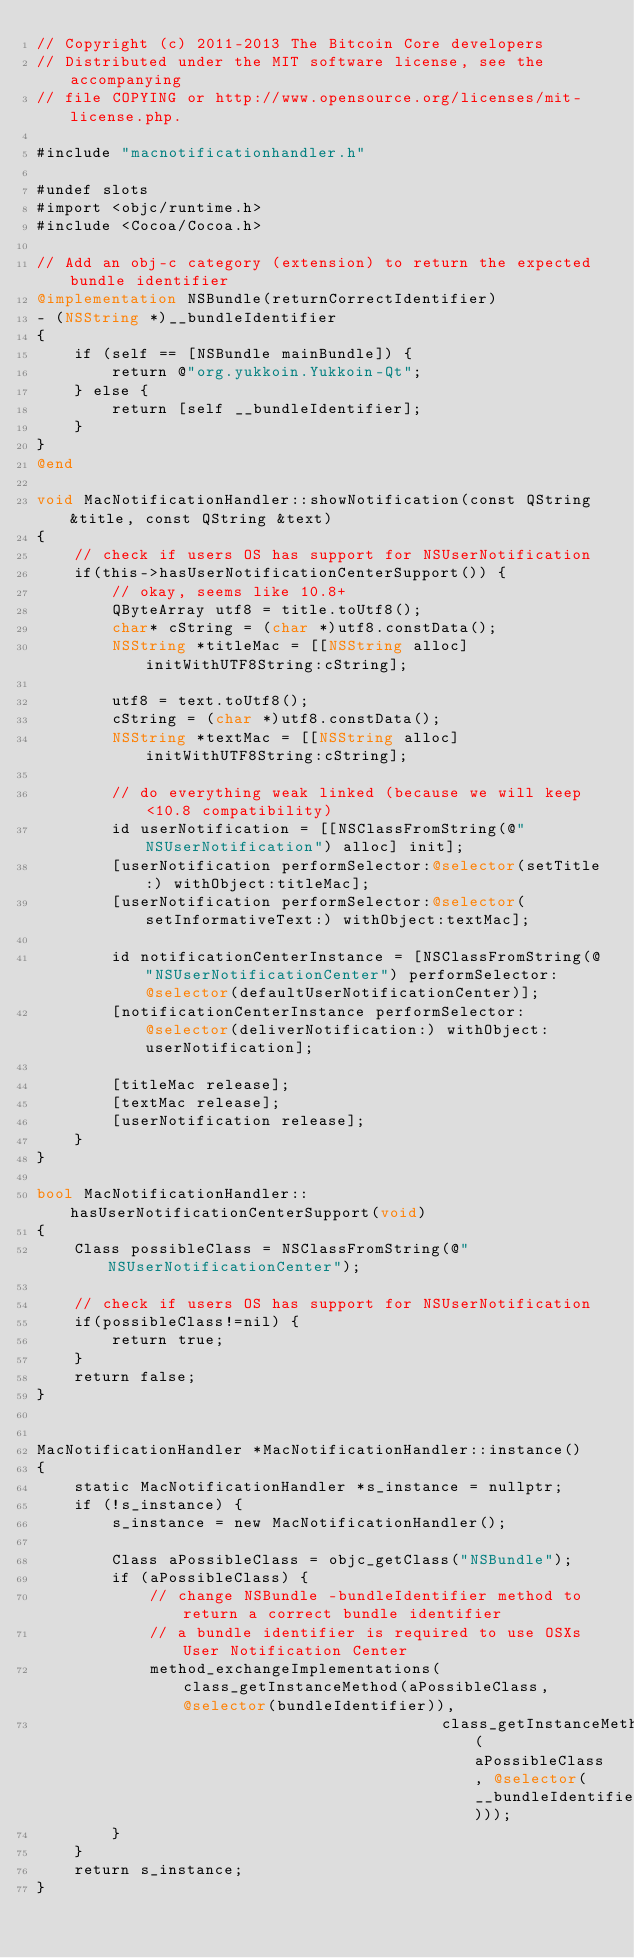<code> <loc_0><loc_0><loc_500><loc_500><_ObjectiveC_>// Copyright (c) 2011-2013 The Bitcoin Core developers
// Distributed under the MIT software license, see the accompanying
// file COPYING or http://www.opensource.org/licenses/mit-license.php.

#include "macnotificationhandler.h"

#undef slots
#import <objc/runtime.h>
#include <Cocoa/Cocoa.h>

// Add an obj-c category (extension) to return the expected bundle identifier
@implementation NSBundle(returnCorrectIdentifier)
- (NSString *)__bundleIdentifier
{
    if (self == [NSBundle mainBundle]) {
        return @"org.yukkoin.Yukkoin-Qt";
    } else {
        return [self __bundleIdentifier];
    }
}
@end

void MacNotificationHandler::showNotification(const QString &title, const QString &text)
{
    // check if users OS has support for NSUserNotification
    if(this->hasUserNotificationCenterSupport()) {
        // okay, seems like 10.8+
        QByteArray utf8 = title.toUtf8();
        char* cString = (char *)utf8.constData();
        NSString *titleMac = [[NSString alloc] initWithUTF8String:cString];

        utf8 = text.toUtf8();
        cString = (char *)utf8.constData();
        NSString *textMac = [[NSString alloc] initWithUTF8String:cString];

        // do everything weak linked (because we will keep <10.8 compatibility)
        id userNotification = [[NSClassFromString(@"NSUserNotification") alloc] init];
        [userNotification performSelector:@selector(setTitle:) withObject:titleMac];
        [userNotification performSelector:@selector(setInformativeText:) withObject:textMac];

        id notificationCenterInstance = [NSClassFromString(@"NSUserNotificationCenter") performSelector:@selector(defaultUserNotificationCenter)];
        [notificationCenterInstance performSelector:@selector(deliverNotification:) withObject:userNotification];

        [titleMac release];
        [textMac release];
        [userNotification release];
    }
}

bool MacNotificationHandler::hasUserNotificationCenterSupport(void)
{
    Class possibleClass = NSClassFromString(@"NSUserNotificationCenter");

    // check if users OS has support for NSUserNotification
    if(possibleClass!=nil) {
        return true;
    }
    return false;
}


MacNotificationHandler *MacNotificationHandler::instance()
{
    static MacNotificationHandler *s_instance = nullptr;
    if (!s_instance) {
        s_instance = new MacNotificationHandler();
        
        Class aPossibleClass = objc_getClass("NSBundle");
        if (aPossibleClass) {
            // change NSBundle -bundleIdentifier method to return a correct bundle identifier
            // a bundle identifier is required to use OSXs User Notification Center
            method_exchangeImplementations(class_getInstanceMethod(aPossibleClass, @selector(bundleIdentifier)),
                                           class_getInstanceMethod(aPossibleClass, @selector(__bundleIdentifier)));
        }
    }
    return s_instance;
}
</code> 